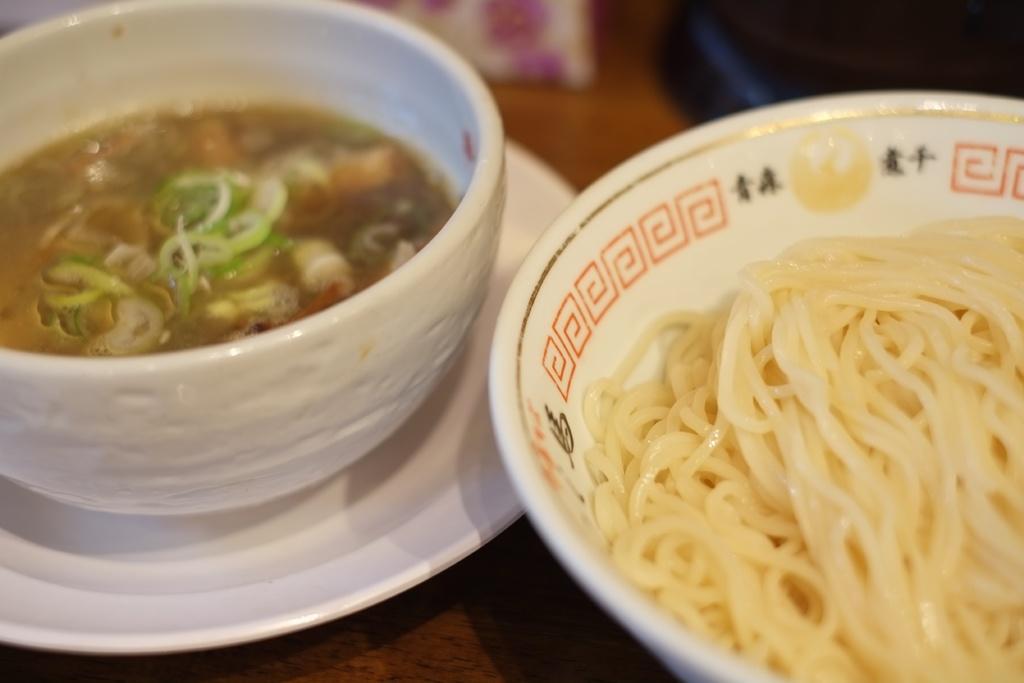In one or two sentences, can you explain what this image depicts? In this picture couple of bowls. I can see noodles in one bowl and some food in another bowl in the plate on the table. 